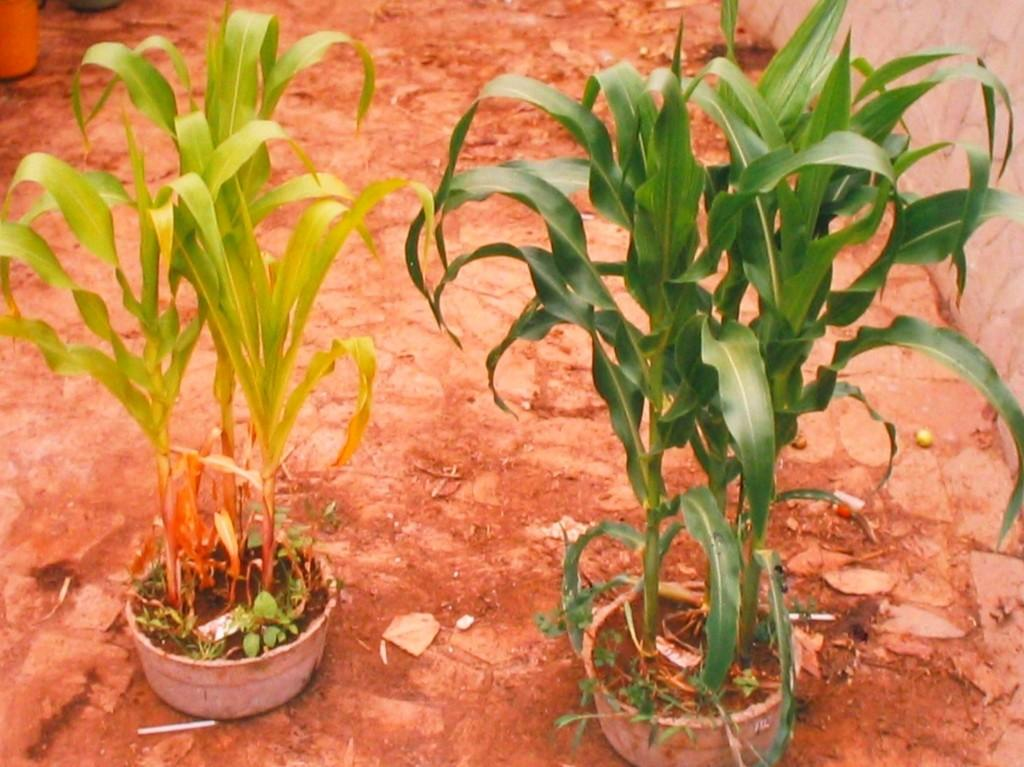How many plant pots are visible in the image? There are two plant pots in the image. Where are the plant pots located? The plant pots are placed on the ground. How many snails can be seen climbing on the plant pots in the image? There are no snails visible in the image; it only shows plant pots placed on the ground. What is the balance of the plant pots in the image? The balance of the plant pots cannot be determined from the image alone, as we cannot see the weight distribution or the stability of the pots. 